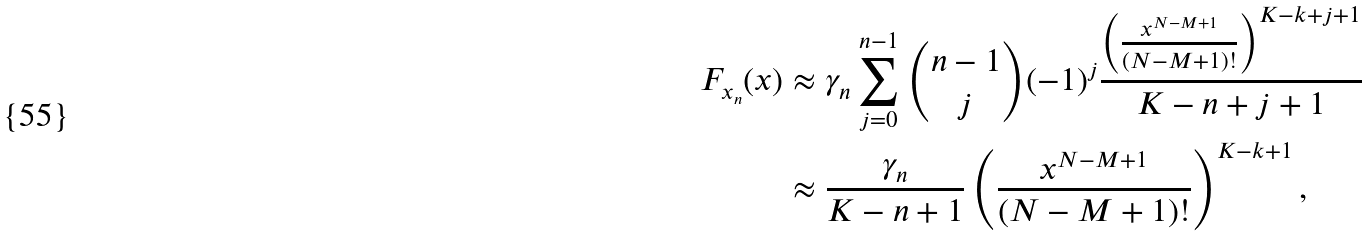<formula> <loc_0><loc_0><loc_500><loc_500>F _ { { x } _ { n } } ( x ) & \approx \gamma _ { n } \sum ^ { n - 1 } _ { j = 0 } { n - 1 \choose j } ( - 1 ) ^ { j } \frac { \left ( \frac { x ^ { N - M + 1 } } { ( N - M + 1 ) ! } \right ) ^ { K - k + j + 1 } } { K - n + j + 1 } \\ & \approx \frac { \gamma _ { n } } { K - n + 1 } \left ( \frac { x ^ { N - M + 1 } } { ( N - M + 1 ) ! } \right ) ^ { K - k + 1 } ,</formula> 